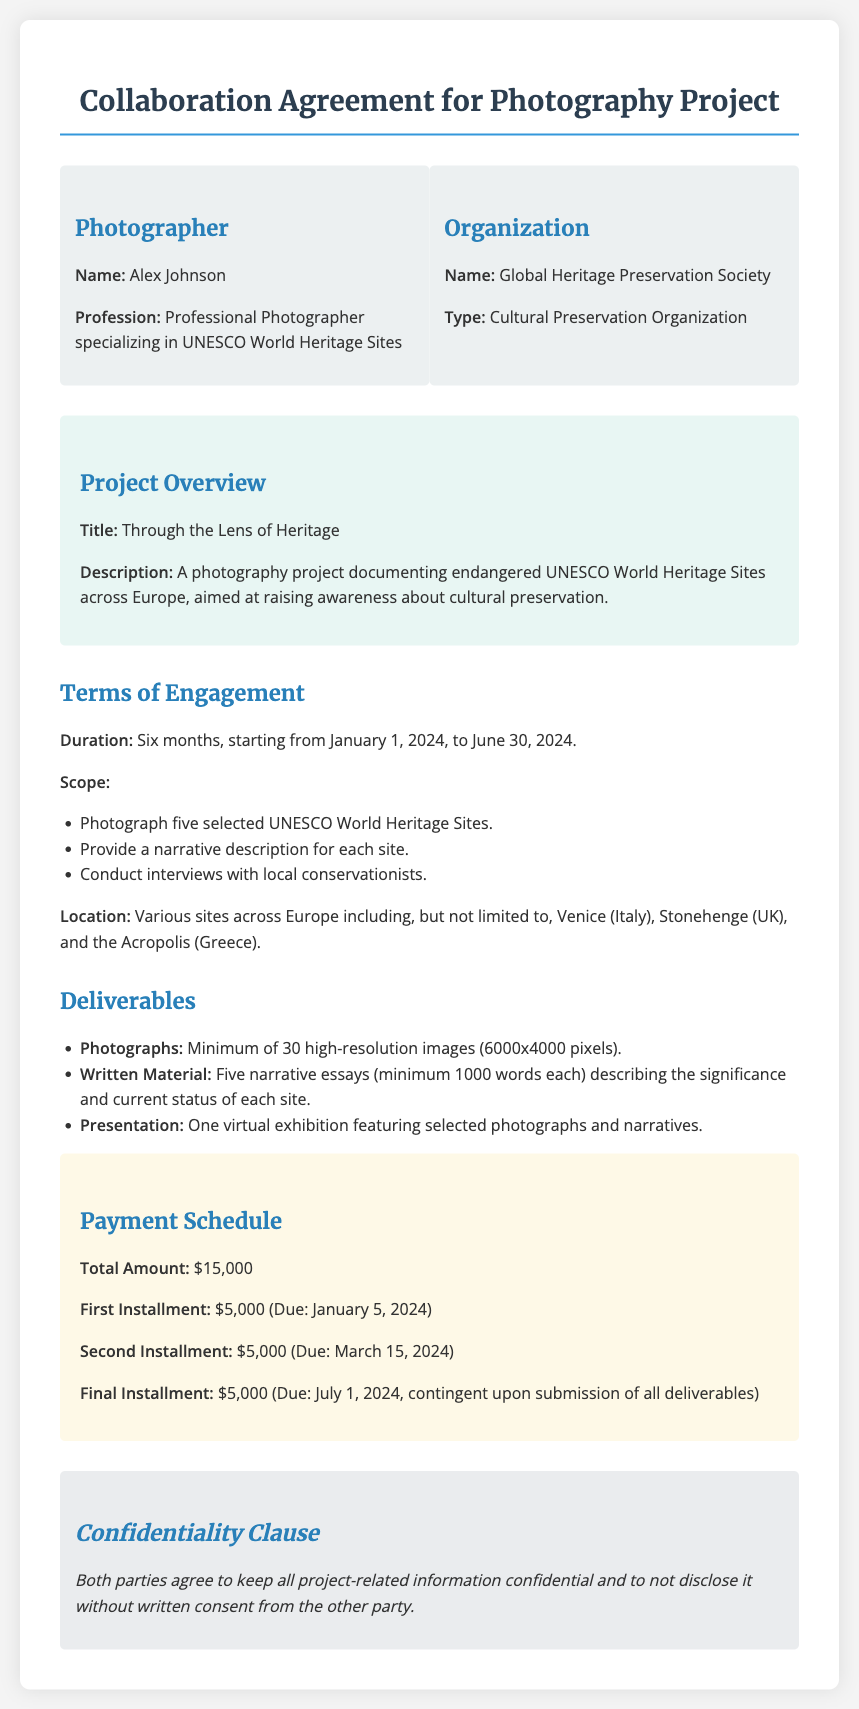What is the name of the photographer? The document specifies the name of the photographer as Alex Johnson.
Answer: Alex Johnson What is the title of the project? The document outlines the title of the project as "Through the Lens of Heritage."
Answer: Through the Lens of Heritage What is the total payment amount for the project? The document states the total payment amount due for the project is $15,000.
Answer: $15,000 When is the final installment due? The document indicates that the final installment is due on July 1, 2024.
Answer: July 1, 2024 How many high-resolution images are required? The document requires a minimum of 30 high-resolution images.
Answer: 30 What is the duration of the project? The project is set to last six months, starting from January 1, 2024, to June 30, 2024.
Answer: Six months What is one of the locations mentioned in the agreement? The document mentions various locations, with Venice, Italy listed as one.
Answer: Venice What type of organization is the Global Heritage Preservation Society? The document describes the organization as a cultural preservation organization.
Answer: Cultural Preservation Organization What is included in the deliverables? One of the deliverables listed is a virtual exhibition featuring selected photographs and narratives.
Answer: Virtual exhibition 